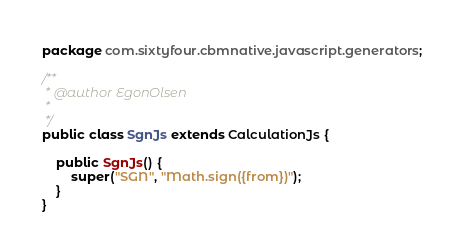<code> <loc_0><loc_0><loc_500><loc_500><_Java_>package com.sixtyfour.cbmnative.javascript.generators;

/**
 * @author EgonOlsen
 * 
 */
public class SgnJs extends CalculationJs {

	public SgnJs() {
		super("SGN", "Math.sign({from})");
	}
}
</code> 